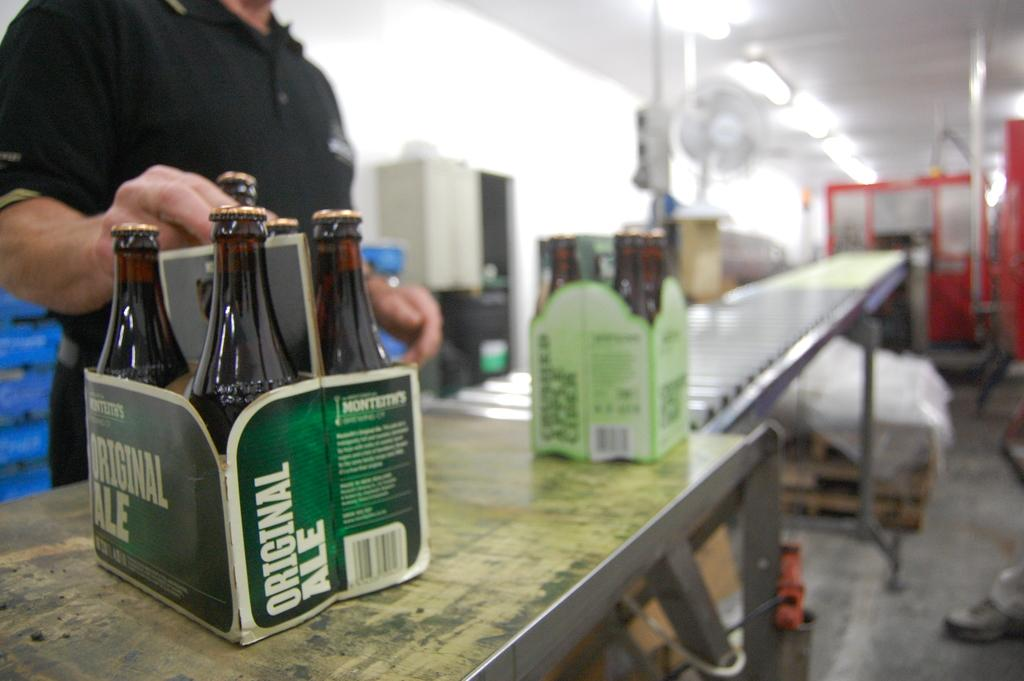<image>
Give a short and clear explanation of the subsequent image. A green case of original ale beer on an assembly line. 